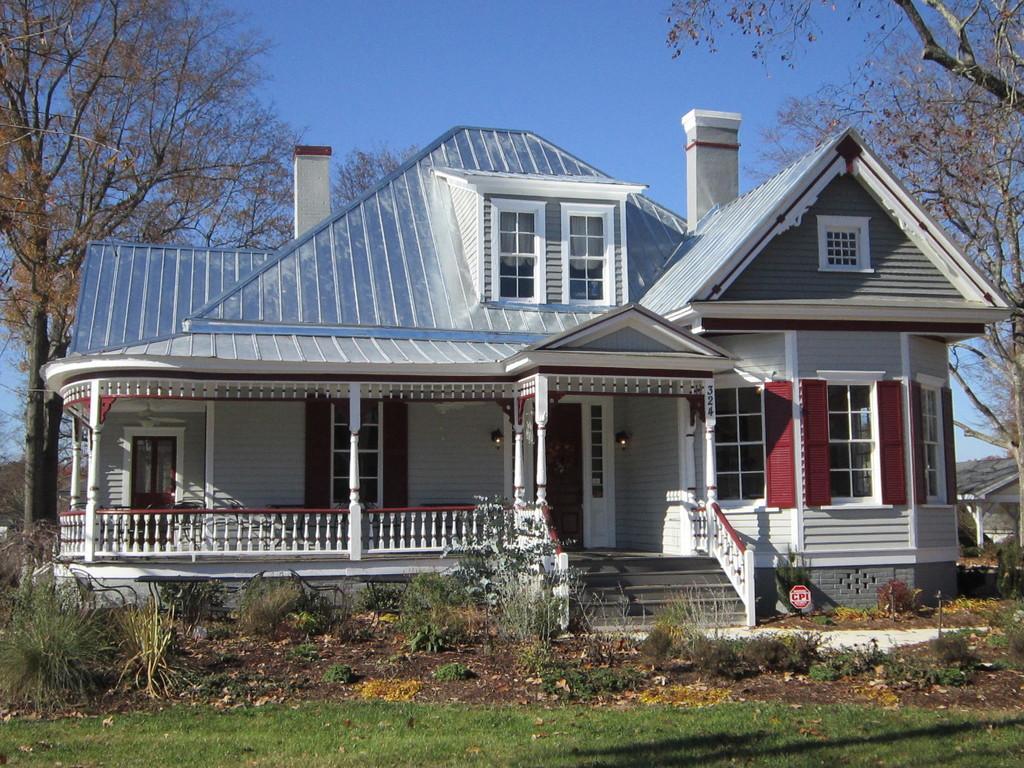Describe this image in one or two sentences. In this image, we can see house in between trees. There are some plants and grass at the bottom of the image. There is a sky at the top of the image. 